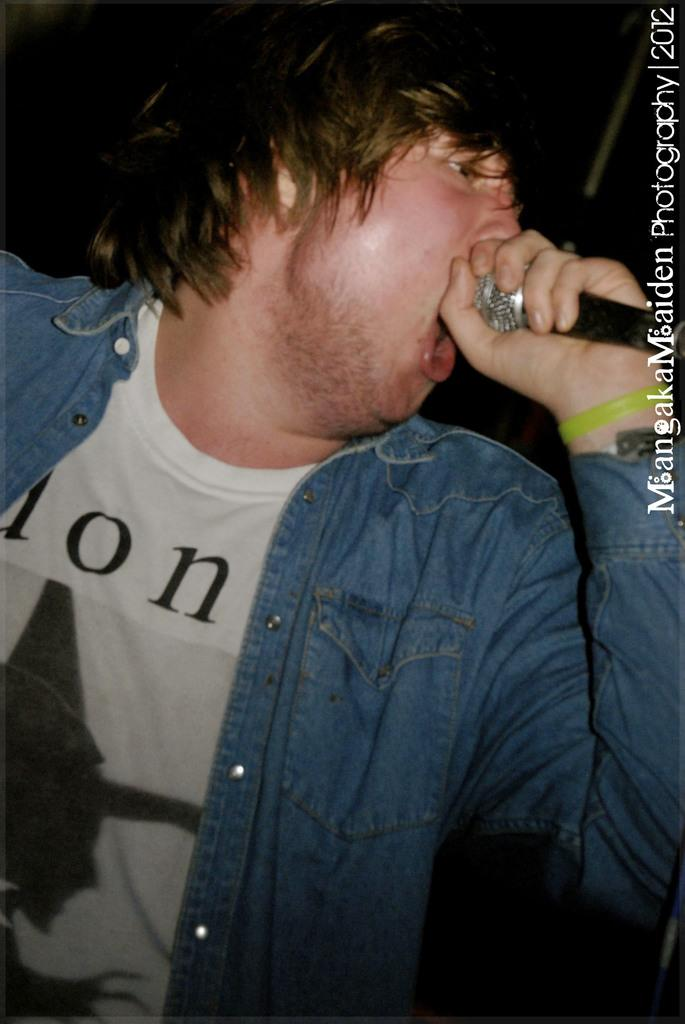Who is the main subject in the image? There is a man in the image. What is the man wearing? The man is wearing a jacket and a white t-shirt. What is the man doing in the image? The man is singing a song and holding a microphone in his hand. Is there any text visible in the image? Yes, there is text visible in the top right corner of the image. How does the man ride the bike while singing in the image? There is no bike present in the image; the man is standing and singing with a microphone in his hand. 